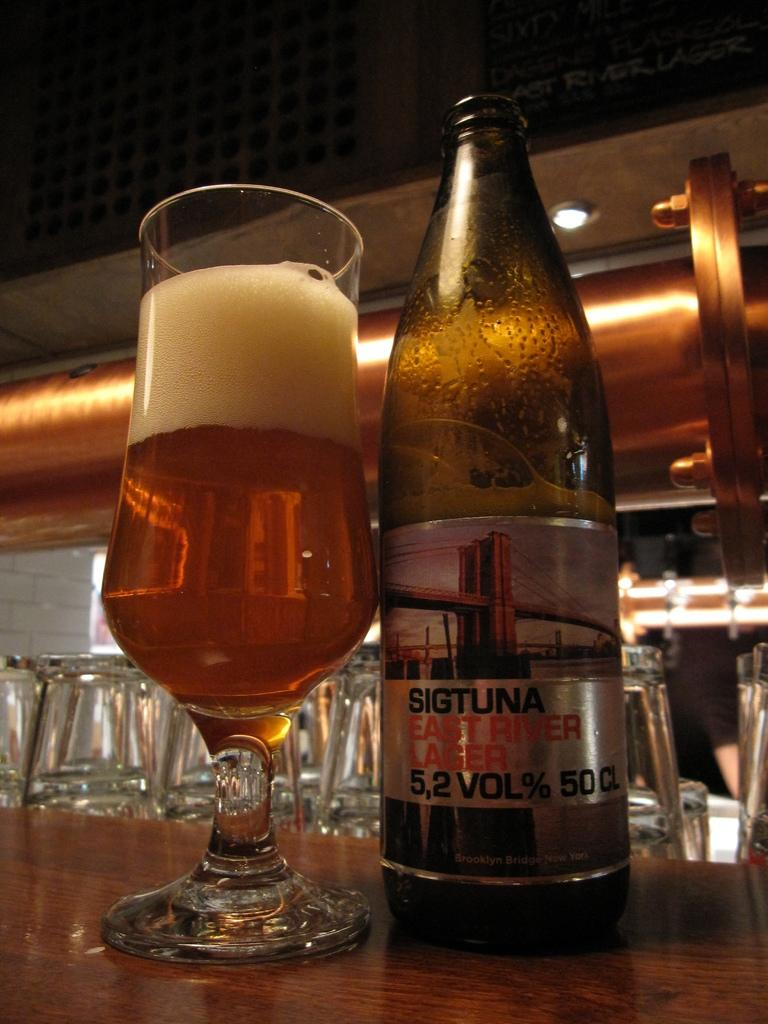<image>
Give a short and clear explanation of the subsequent image. A bottle of Sigtuna East River Lager sits next to a glass of beer on the bar. 